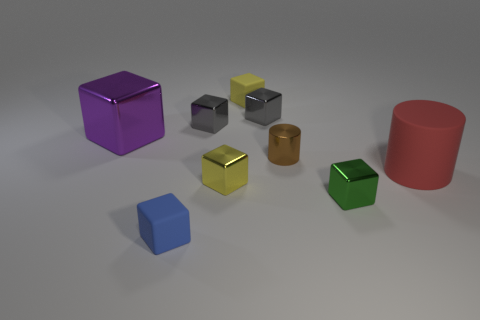Subtract all small cubes. How many cubes are left? 1 Add 1 big red rubber things. How many objects exist? 10 Subtract all blue cubes. How many cubes are left? 6 Subtract all brown cylinders. How many yellow cubes are left? 2 Subtract 2 cylinders. How many cylinders are left? 0 Subtract all cylinders. How many objects are left? 7 Add 5 small cyan matte spheres. How many small cyan matte spheres exist? 5 Subtract 0 red blocks. How many objects are left? 9 Subtract all brown blocks. Subtract all red spheres. How many blocks are left? 7 Subtract all green metallic things. Subtract all matte objects. How many objects are left? 5 